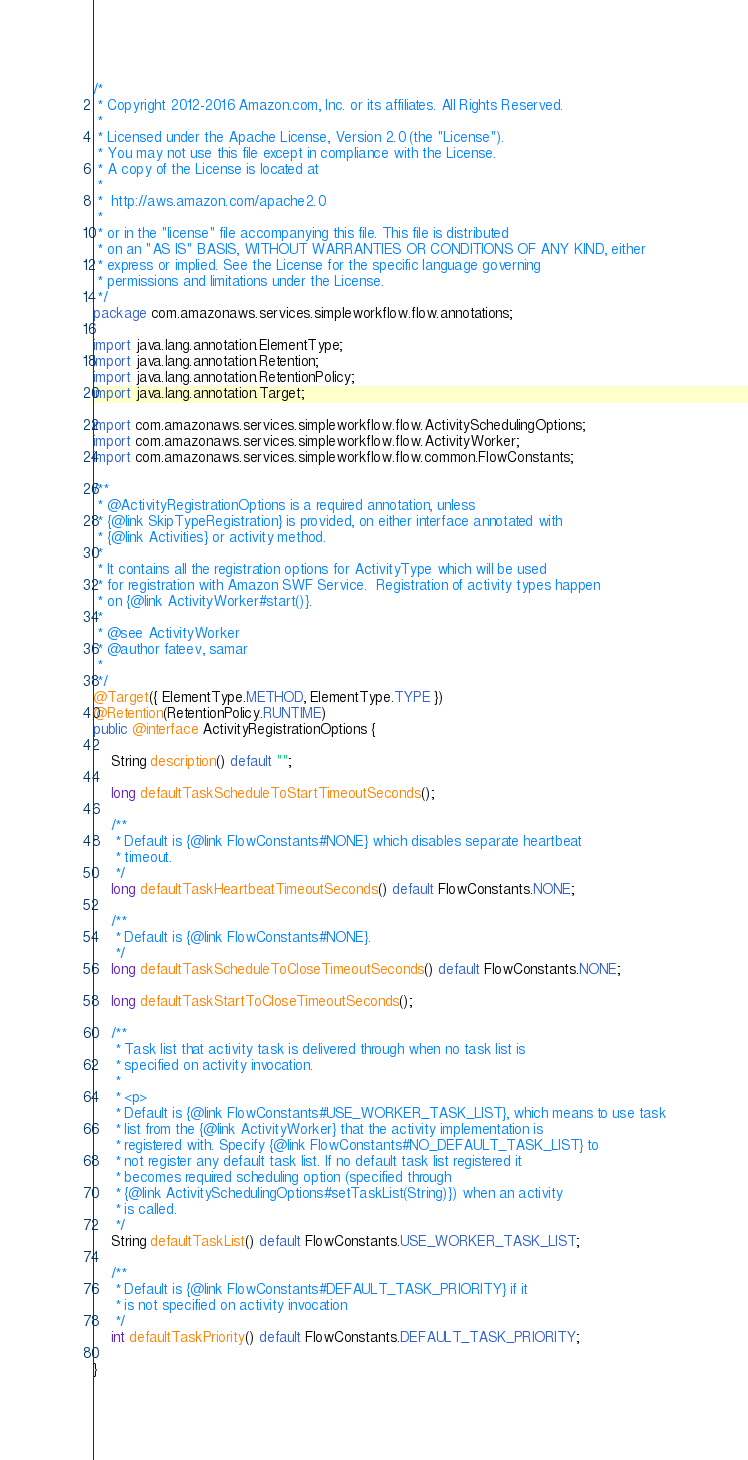Convert code to text. <code><loc_0><loc_0><loc_500><loc_500><_Java_>/*
 * Copyright 2012-2016 Amazon.com, Inc. or its affiliates. All Rights Reserved.
 *
 * Licensed under the Apache License, Version 2.0 (the "License").
 * You may not use this file except in compliance with the License.
 * A copy of the License is located at
 *
 *  http://aws.amazon.com/apache2.0
 *
 * or in the "license" file accompanying this file. This file is distributed
 * on an "AS IS" BASIS, WITHOUT WARRANTIES OR CONDITIONS OF ANY KIND, either
 * express or implied. See the License for the specific language governing
 * permissions and limitations under the License.
 */
package com.amazonaws.services.simpleworkflow.flow.annotations;

import java.lang.annotation.ElementType;
import java.lang.annotation.Retention;
import java.lang.annotation.RetentionPolicy;
import java.lang.annotation.Target;

import com.amazonaws.services.simpleworkflow.flow.ActivitySchedulingOptions;
import com.amazonaws.services.simpleworkflow.flow.ActivityWorker;
import com.amazonaws.services.simpleworkflow.flow.common.FlowConstants;

/**
 * @ActivityRegistrationOptions is a required annotation, unless 
 * {@link SkipTypeRegistration} is provided, on either interface annotated with 
 * {@link Activities} or activity method.
 * 
 * It contains all the registration options for ActivityType which will be used 
 * for registration with Amazon SWF Service.  Registration of activity types happen
 * on {@link ActivityWorker#start()}.
 * 
 * @see ActivityWorker
 * @author fateev, samar
 * 
 */
@Target({ ElementType.METHOD, ElementType.TYPE })
@Retention(RetentionPolicy.RUNTIME)
public @interface ActivityRegistrationOptions {

    String description() default "";

    long defaultTaskScheduleToStartTimeoutSeconds();

    /**
     * Default is {@link FlowConstants#NONE} which disables separate heartbeat
     * timeout.
     */
    long defaultTaskHeartbeatTimeoutSeconds() default FlowConstants.NONE;

    /**
     * Default is {@link FlowConstants#NONE}. 
     */
    long defaultTaskScheduleToCloseTimeoutSeconds() default FlowConstants.NONE;

    long defaultTaskStartToCloseTimeoutSeconds();

    /**
     * Task list that activity task is delivered through when no task list is
     * specified on activity invocation.
     * 
     * <p>
     * Default is {@link FlowConstants#USE_WORKER_TASK_LIST}, which means to use task
     * list from the {@link ActivityWorker} that the activity implementation is
     * registered with. Specify {@link FlowConstants#NO_DEFAULT_TASK_LIST} to
     * not register any default task list. If no default task list registered it
     * becomes required scheduling option (specified through
     * {@link ActivitySchedulingOptions#setTaskList(String)}) when an activity
     * is called.
     */
    String defaultTaskList() default FlowConstants.USE_WORKER_TASK_LIST;

    /**
     * Default is {@link FlowConstants#DEFAULT_TASK_PRIORITY} if it
     * is not specified on activity invocation
     */
    int defaultTaskPriority() default FlowConstants.DEFAULT_TASK_PRIORITY;
    
}
</code> 